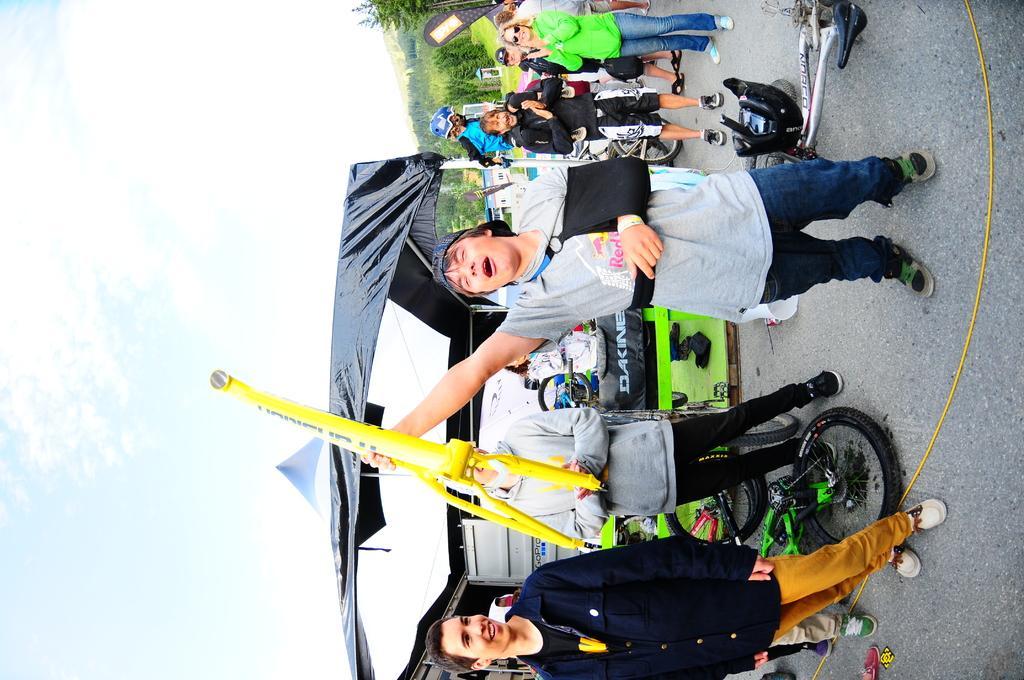Can you describe this image briefly? In this image I can see a person standing wearing gray color shirt, blue color pant holding some object which is in yellow color. At left and right I can see other persons standing. At back I can see trees in green color, and sky in white and blue color. 